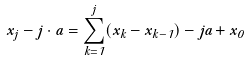<formula> <loc_0><loc_0><loc_500><loc_500>x _ { j } - j \cdot a = \sum _ { k = 1 } ^ { j } ( x _ { k } - x _ { k - 1 } ) - j a + x _ { 0 }</formula> 